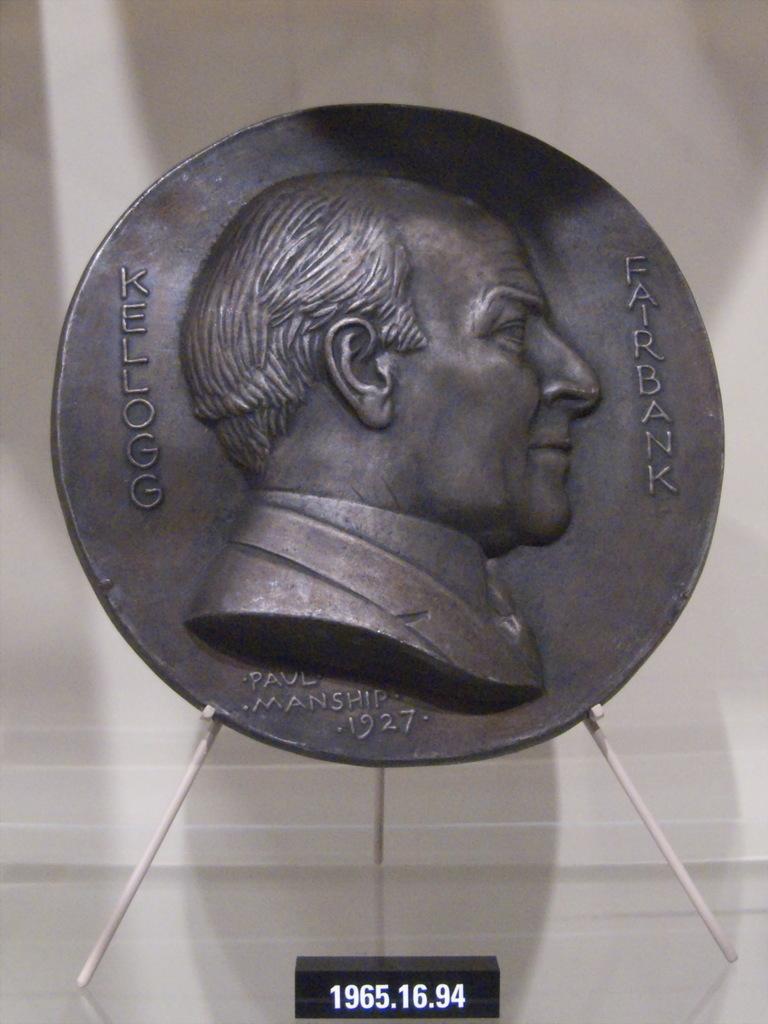What is the number at the bottom?
Provide a succinct answer. 1965.16.94. 